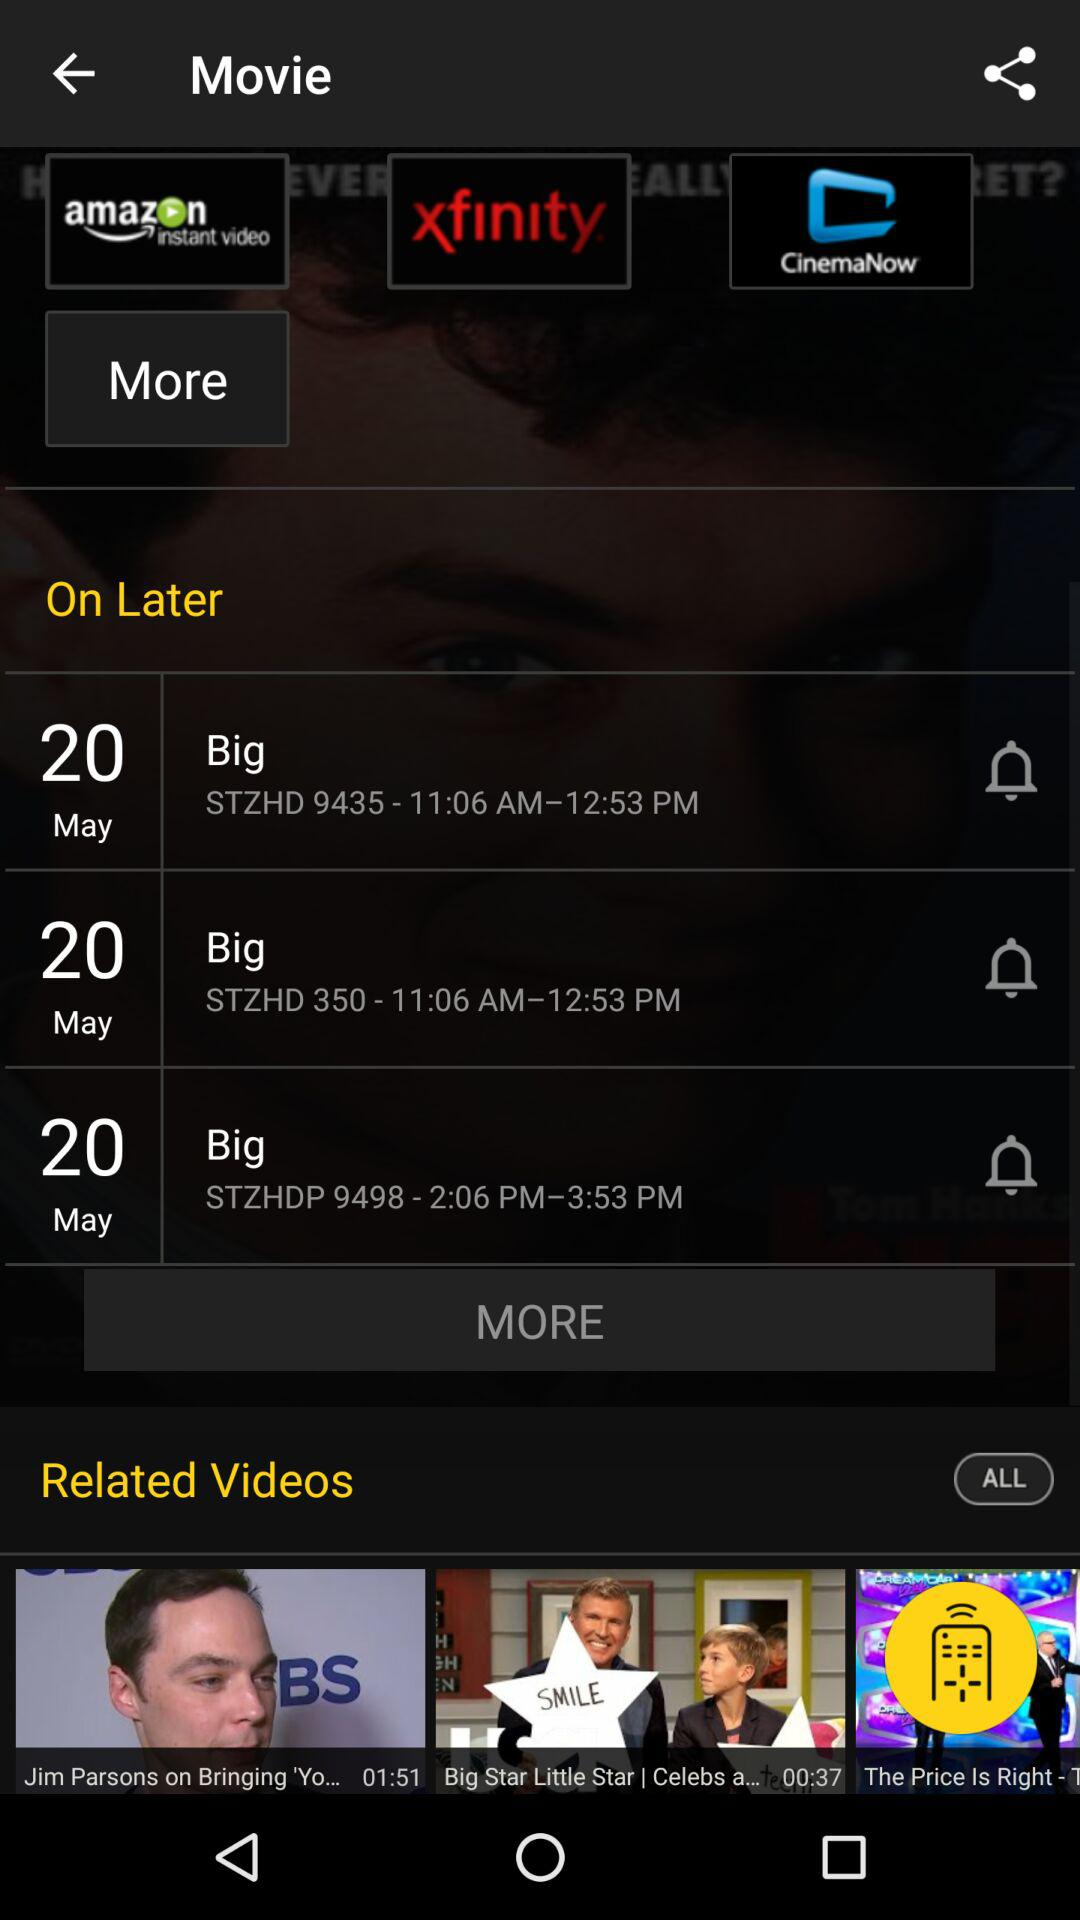What is the time of STZHD 9435? The time is from 11:06 AM to 12:53 PM. 